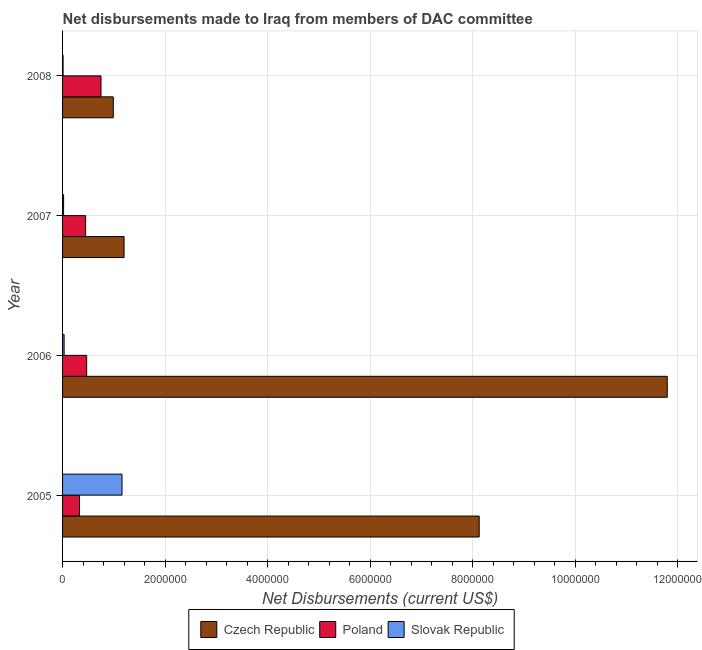Are the number of bars per tick equal to the number of legend labels?
Offer a terse response. Yes. Are the number of bars on each tick of the Y-axis equal?
Your response must be concise. Yes. How many bars are there on the 1st tick from the bottom?
Your answer should be compact. 3. What is the net disbursements made by poland in 2006?
Offer a very short reply. 4.70e+05. Across all years, what is the maximum net disbursements made by czech republic?
Ensure brevity in your answer.  1.18e+07. Across all years, what is the minimum net disbursements made by poland?
Ensure brevity in your answer.  3.30e+05. What is the total net disbursements made by czech republic in the graph?
Your answer should be very brief. 2.21e+07. What is the difference between the net disbursements made by poland in 2006 and that in 2008?
Provide a succinct answer. -2.80e+05. What is the difference between the net disbursements made by slovak republic in 2007 and the net disbursements made by czech republic in 2008?
Give a very brief answer. -9.70e+05. What is the average net disbursements made by slovak republic per year?
Provide a succinct answer. 3.05e+05. In the year 2005, what is the difference between the net disbursements made by slovak republic and net disbursements made by poland?
Your answer should be compact. 8.30e+05. What is the ratio of the net disbursements made by poland in 2006 to that in 2007?
Your response must be concise. 1.04. Is the difference between the net disbursements made by poland in 2005 and 2006 greater than the difference between the net disbursements made by slovak republic in 2005 and 2006?
Your answer should be compact. No. What is the difference between the highest and the second highest net disbursements made by slovak republic?
Your response must be concise. 1.13e+06. What is the difference between the highest and the lowest net disbursements made by slovak republic?
Your answer should be very brief. 1.15e+06. What does the 3rd bar from the top in 2006 represents?
Offer a terse response. Czech Republic. How many bars are there?
Your answer should be compact. 12. How many years are there in the graph?
Make the answer very short. 4. What is the difference between two consecutive major ticks on the X-axis?
Provide a short and direct response. 2.00e+06. Are the values on the major ticks of X-axis written in scientific E-notation?
Your answer should be very brief. No. Does the graph contain any zero values?
Provide a succinct answer. No. What is the title of the graph?
Your answer should be compact. Net disbursements made to Iraq from members of DAC committee. What is the label or title of the X-axis?
Offer a terse response. Net Disbursements (current US$). What is the Net Disbursements (current US$) of Czech Republic in 2005?
Ensure brevity in your answer.  8.13e+06. What is the Net Disbursements (current US$) of Slovak Republic in 2005?
Provide a short and direct response. 1.16e+06. What is the Net Disbursements (current US$) in Czech Republic in 2006?
Your response must be concise. 1.18e+07. What is the Net Disbursements (current US$) in Slovak Republic in 2006?
Offer a terse response. 3.00e+04. What is the Net Disbursements (current US$) of Czech Republic in 2007?
Your response must be concise. 1.20e+06. What is the Net Disbursements (current US$) of Poland in 2007?
Offer a terse response. 4.50e+05. What is the Net Disbursements (current US$) of Slovak Republic in 2007?
Your answer should be very brief. 2.00e+04. What is the Net Disbursements (current US$) in Czech Republic in 2008?
Keep it short and to the point. 9.90e+05. What is the Net Disbursements (current US$) in Poland in 2008?
Provide a short and direct response. 7.50e+05. What is the Net Disbursements (current US$) of Slovak Republic in 2008?
Offer a terse response. 10000. Across all years, what is the maximum Net Disbursements (current US$) in Czech Republic?
Make the answer very short. 1.18e+07. Across all years, what is the maximum Net Disbursements (current US$) of Poland?
Your response must be concise. 7.50e+05. Across all years, what is the maximum Net Disbursements (current US$) in Slovak Republic?
Keep it short and to the point. 1.16e+06. Across all years, what is the minimum Net Disbursements (current US$) in Czech Republic?
Keep it short and to the point. 9.90e+05. Across all years, what is the minimum Net Disbursements (current US$) of Poland?
Give a very brief answer. 3.30e+05. What is the total Net Disbursements (current US$) of Czech Republic in the graph?
Your answer should be very brief. 2.21e+07. What is the total Net Disbursements (current US$) of Poland in the graph?
Ensure brevity in your answer.  2.00e+06. What is the total Net Disbursements (current US$) in Slovak Republic in the graph?
Your answer should be very brief. 1.22e+06. What is the difference between the Net Disbursements (current US$) of Czech Republic in 2005 and that in 2006?
Keep it short and to the point. -3.67e+06. What is the difference between the Net Disbursements (current US$) of Poland in 2005 and that in 2006?
Make the answer very short. -1.40e+05. What is the difference between the Net Disbursements (current US$) of Slovak Republic in 2005 and that in 2006?
Your answer should be very brief. 1.13e+06. What is the difference between the Net Disbursements (current US$) in Czech Republic in 2005 and that in 2007?
Your answer should be very brief. 6.93e+06. What is the difference between the Net Disbursements (current US$) in Slovak Republic in 2005 and that in 2007?
Your response must be concise. 1.14e+06. What is the difference between the Net Disbursements (current US$) in Czech Republic in 2005 and that in 2008?
Ensure brevity in your answer.  7.14e+06. What is the difference between the Net Disbursements (current US$) in Poland in 2005 and that in 2008?
Make the answer very short. -4.20e+05. What is the difference between the Net Disbursements (current US$) in Slovak Republic in 2005 and that in 2008?
Your answer should be very brief. 1.15e+06. What is the difference between the Net Disbursements (current US$) of Czech Republic in 2006 and that in 2007?
Make the answer very short. 1.06e+07. What is the difference between the Net Disbursements (current US$) of Slovak Republic in 2006 and that in 2007?
Give a very brief answer. 10000. What is the difference between the Net Disbursements (current US$) of Czech Republic in 2006 and that in 2008?
Offer a very short reply. 1.08e+07. What is the difference between the Net Disbursements (current US$) in Poland in 2006 and that in 2008?
Make the answer very short. -2.80e+05. What is the difference between the Net Disbursements (current US$) in Czech Republic in 2007 and that in 2008?
Provide a succinct answer. 2.10e+05. What is the difference between the Net Disbursements (current US$) in Slovak Republic in 2007 and that in 2008?
Offer a terse response. 10000. What is the difference between the Net Disbursements (current US$) in Czech Republic in 2005 and the Net Disbursements (current US$) in Poland in 2006?
Provide a short and direct response. 7.66e+06. What is the difference between the Net Disbursements (current US$) of Czech Republic in 2005 and the Net Disbursements (current US$) of Slovak Republic in 2006?
Make the answer very short. 8.10e+06. What is the difference between the Net Disbursements (current US$) of Poland in 2005 and the Net Disbursements (current US$) of Slovak Republic in 2006?
Your response must be concise. 3.00e+05. What is the difference between the Net Disbursements (current US$) of Czech Republic in 2005 and the Net Disbursements (current US$) of Poland in 2007?
Your answer should be very brief. 7.68e+06. What is the difference between the Net Disbursements (current US$) in Czech Republic in 2005 and the Net Disbursements (current US$) in Slovak Republic in 2007?
Offer a terse response. 8.11e+06. What is the difference between the Net Disbursements (current US$) of Czech Republic in 2005 and the Net Disbursements (current US$) of Poland in 2008?
Provide a short and direct response. 7.38e+06. What is the difference between the Net Disbursements (current US$) in Czech Republic in 2005 and the Net Disbursements (current US$) in Slovak Republic in 2008?
Your response must be concise. 8.12e+06. What is the difference between the Net Disbursements (current US$) of Czech Republic in 2006 and the Net Disbursements (current US$) of Poland in 2007?
Offer a very short reply. 1.14e+07. What is the difference between the Net Disbursements (current US$) in Czech Republic in 2006 and the Net Disbursements (current US$) in Slovak Republic in 2007?
Keep it short and to the point. 1.18e+07. What is the difference between the Net Disbursements (current US$) in Poland in 2006 and the Net Disbursements (current US$) in Slovak Republic in 2007?
Provide a short and direct response. 4.50e+05. What is the difference between the Net Disbursements (current US$) in Czech Republic in 2006 and the Net Disbursements (current US$) in Poland in 2008?
Provide a succinct answer. 1.10e+07. What is the difference between the Net Disbursements (current US$) in Czech Republic in 2006 and the Net Disbursements (current US$) in Slovak Republic in 2008?
Offer a terse response. 1.18e+07. What is the difference between the Net Disbursements (current US$) of Czech Republic in 2007 and the Net Disbursements (current US$) of Slovak Republic in 2008?
Your response must be concise. 1.19e+06. What is the average Net Disbursements (current US$) of Czech Republic per year?
Your answer should be compact. 5.53e+06. What is the average Net Disbursements (current US$) of Poland per year?
Provide a short and direct response. 5.00e+05. What is the average Net Disbursements (current US$) in Slovak Republic per year?
Make the answer very short. 3.05e+05. In the year 2005, what is the difference between the Net Disbursements (current US$) of Czech Republic and Net Disbursements (current US$) of Poland?
Keep it short and to the point. 7.80e+06. In the year 2005, what is the difference between the Net Disbursements (current US$) of Czech Republic and Net Disbursements (current US$) of Slovak Republic?
Make the answer very short. 6.97e+06. In the year 2005, what is the difference between the Net Disbursements (current US$) of Poland and Net Disbursements (current US$) of Slovak Republic?
Give a very brief answer. -8.30e+05. In the year 2006, what is the difference between the Net Disbursements (current US$) in Czech Republic and Net Disbursements (current US$) in Poland?
Ensure brevity in your answer.  1.13e+07. In the year 2006, what is the difference between the Net Disbursements (current US$) of Czech Republic and Net Disbursements (current US$) of Slovak Republic?
Your response must be concise. 1.18e+07. In the year 2007, what is the difference between the Net Disbursements (current US$) in Czech Republic and Net Disbursements (current US$) in Poland?
Offer a very short reply. 7.50e+05. In the year 2007, what is the difference between the Net Disbursements (current US$) in Czech Republic and Net Disbursements (current US$) in Slovak Republic?
Your answer should be compact. 1.18e+06. In the year 2008, what is the difference between the Net Disbursements (current US$) of Czech Republic and Net Disbursements (current US$) of Slovak Republic?
Your answer should be compact. 9.80e+05. In the year 2008, what is the difference between the Net Disbursements (current US$) of Poland and Net Disbursements (current US$) of Slovak Republic?
Ensure brevity in your answer.  7.40e+05. What is the ratio of the Net Disbursements (current US$) in Czech Republic in 2005 to that in 2006?
Give a very brief answer. 0.69. What is the ratio of the Net Disbursements (current US$) of Poland in 2005 to that in 2006?
Give a very brief answer. 0.7. What is the ratio of the Net Disbursements (current US$) in Slovak Republic in 2005 to that in 2006?
Offer a very short reply. 38.67. What is the ratio of the Net Disbursements (current US$) of Czech Republic in 2005 to that in 2007?
Your response must be concise. 6.78. What is the ratio of the Net Disbursements (current US$) of Poland in 2005 to that in 2007?
Offer a terse response. 0.73. What is the ratio of the Net Disbursements (current US$) of Slovak Republic in 2005 to that in 2007?
Give a very brief answer. 58. What is the ratio of the Net Disbursements (current US$) of Czech Republic in 2005 to that in 2008?
Make the answer very short. 8.21. What is the ratio of the Net Disbursements (current US$) in Poland in 2005 to that in 2008?
Keep it short and to the point. 0.44. What is the ratio of the Net Disbursements (current US$) of Slovak Republic in 2005 to that in 2008?
Your response must be concise. 116. What is the ratio of the Net Disbursements (current US$) in Czech Republic in 2006 to that in 2007?
Your answer should be compact. 9.83. What is the ratio of the Net Disbursements (current US$) in Poland in 2006 to that in 2007?
Your response must be concise. 1.04. What is the ratio of the Net Disbursements (current US$) in Slovak Republic in 2006 to that in 2007?
Your response must be concise. 1.5. What is the ratio of the Net Disbursements (current US$) of Czech Republic in 2006 to that in 2008?
Provide a succinct answer. 11.92. What is the ratio of the Net Disbursements (current US$) of Poland in 2006 to that in 2008?
Offer a terse response. 0.63. What is the ratio of the Net Disbursements (current US$) in Czech Republic in 2007 to that in 2008?
Your answer should be very brief. 1.21. What is the ratio of the Net Disbursements (current US$) of Poland in 2007 to that in 2008?
Your response must be concise. 0.6. What is the difference between the highest and the second highest Net Disbursements (current US$) in Czech Republic?
Provide a succinct answer. 3.67e+06. What is the difference between the highest and the second highest Net Disbursements (current US$) in Poland?
Your response must be concise. 2.80e+05. What is the difference between the highest and the second highest Net Disbursements (current US$) of Slovak Republic?
Offer a very short reply. 1.13e+06. What is the difference between the highest and the lowest Net Disbursements (current US$) in Czech Republic?
Your answer should be very brief. 1.08e+07. What is the difference between the highest and the lowest Net Disbursements (current US$) of Slovak Republic?
Make the answer very short. 1.15e+06. 